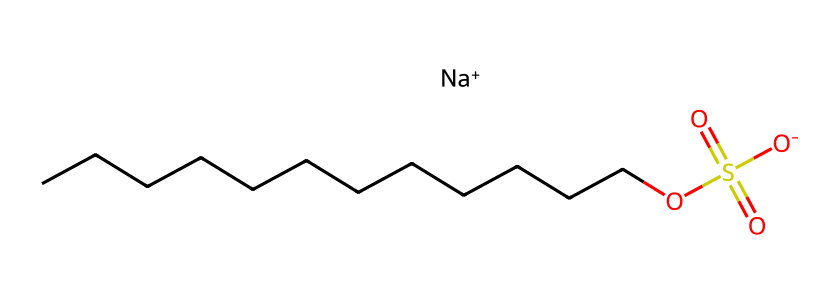What is the total number of carbon atoms in sodium lauryl sulfate? The SMILES representation shows a long carbon chain, which can be counted. There are 12 carbon atoms represented by "CCCCCCCCCCCC".
Answer: 12 What type of ion is included in the structure of sodium lauryl sulfate? The chemical includes "Na+" which indicates the presence of a sodium ion. This is typical for ionic compounds like sodium lauryl sulfate.
Answer: sodium How many oxygen atoms are in sodium lauryl sulfate? In the SMILES representation, one can see "O" for each oxygen atom, which totals to 4 in the structure. Two are part of the sulfate group "OS(=O)(=O)" and the remaining two are part of the hydrocarbon chain and the anionic form of the sulfate.
Answer: 4 What does the "OS(=O)(=O)" part indicate about the sulfate group? This section indicates the presence of a sulfate functional group, characterized by the sulfur atom bonded to four oxygen atoms, demonstrating it’s a sulfate. The "=" indicates double bonds with oxygens.
Answer: sulfate Why is sodium lauryl sulfate effective as a detergent? The long hydrophobic carbon chain (12 carbons) helps in removing grease and oil, while the sulfate group provides a hydrophilic end which allows it to interact with water, making it an effective surfactant and detergent.
Answer: effective surfactant What role does sodium play in sodium lauryl sulfate? Sodium acts as a counterion to balance the charge of the sulfate group, making the compound more soluble in water. The positive charge of sodium assists in stabilizing the overall structure.
Answer: counterion What property is indicated by the "sulfate" group in sodium lauryl sulfate? The presence of sulfate typically indicates that the compound is an anionic surfactant, which is known for its ability to create foaming and cleansing properties, particularly useful in bubble baths and shampoos.
Answer: anionic surfactant 